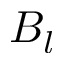<formula> <loc_0><loc_0><loc_500><loc_500>B _ { l }</formula> 